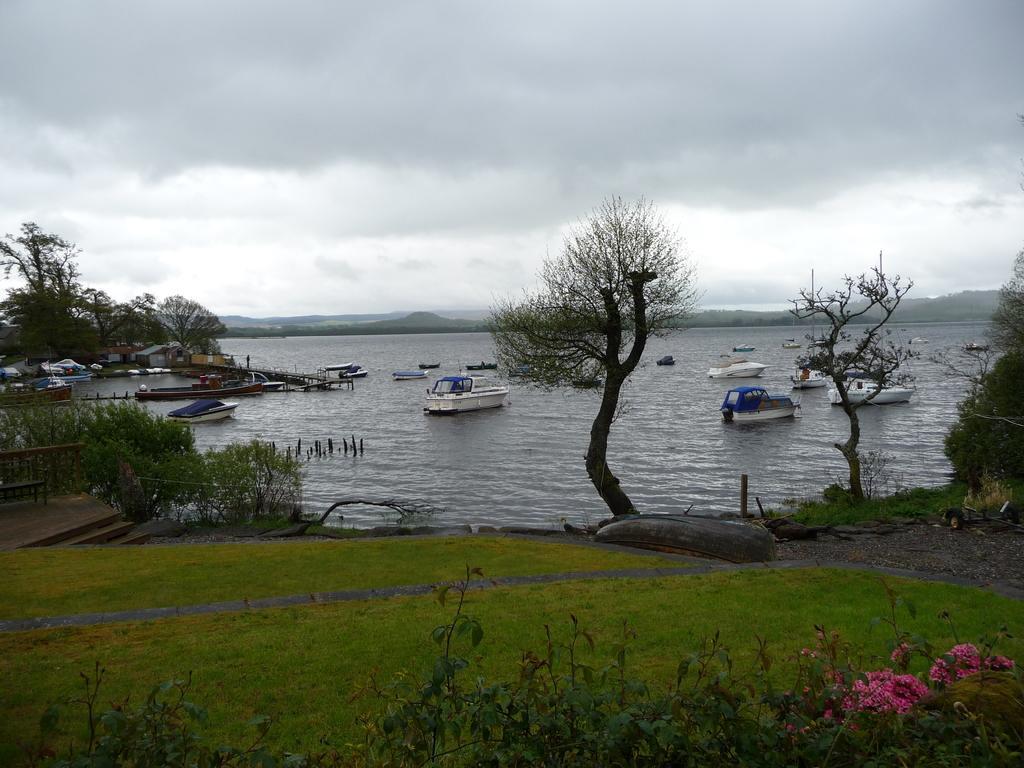Could you give a brief overview of what you see in this image? In this picture we can see few boats on the water, and we can find few houses, trees and clouds, at the right bottom of the image we can see few flowers. 